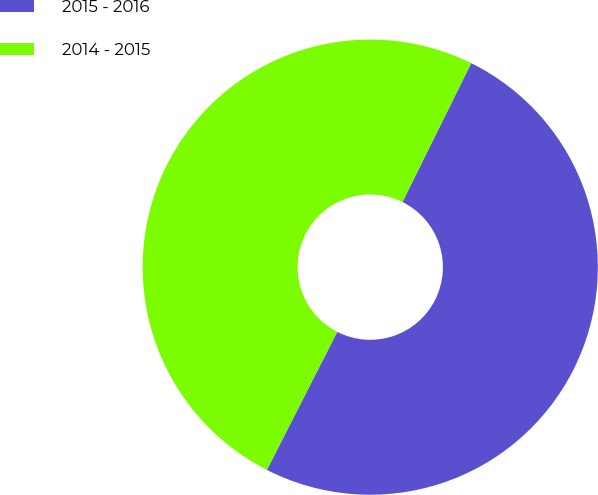Convert chart. <chart><loc_0><loc_0><loc_500><loc_500><pie_chart><fcel>2015 - 2016<fcel>2014 - 2015<nl><fcel>50.19%<fcel>49.81%<nl></chart> 